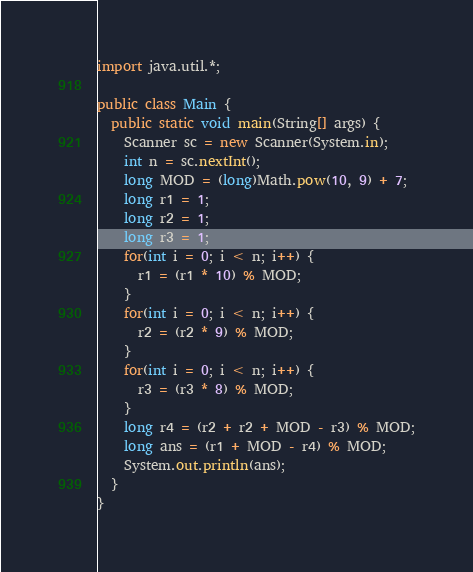Convert code to text. <code><loc_0><loc_0><loc_500><loc_500><_Java_>import java.util.*;

public class Main {
  public static void main(String[] args) {
    Scanner sc = new Scanner(System.in);
    int n = sc.nextInt();
    long MOD = (long)Math.pow(10, 9) + 7;
    long r1 = 1;
    long r2 = 1;
    long r3 = 1;
    for(int i = 0; i < n; i++) {
      r1 = (r1 * 10) % MOD;
    }
    for(int i = 0; i < n; i++) {
      r2 = (r2 * 9) % MOD;
    }
    for(int i = 0; i < n; i++) {
      r3 = (r3 * 8) % MOD;
    }
    long r4 = (r2 + r2 + MOD - r3) % MOD;
    long ans = (r1 + MOD - r4) % MOD;
    System.out.println(ans);
  }
}
</code> 